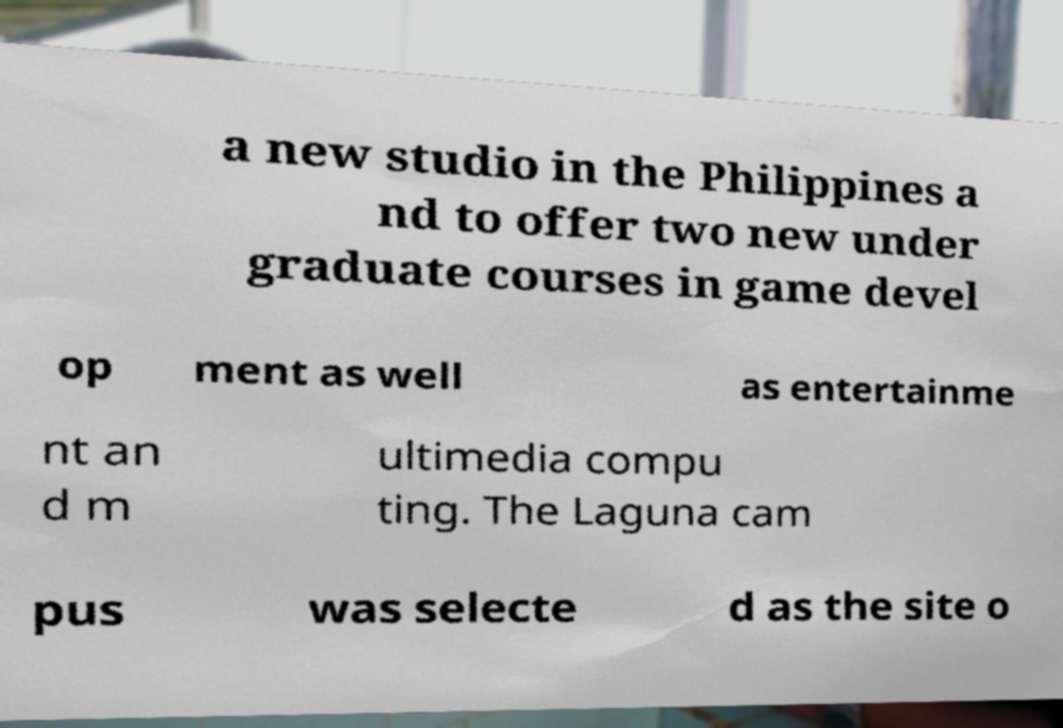Please identify and transcribe the text found in this image. a new studio in the Philippines a nd to offer two new under graduate courses in game devel op ment as well as entertainme nt an d m ultimedia compu ting. The Laguna cam pus was selecte d as the site o 